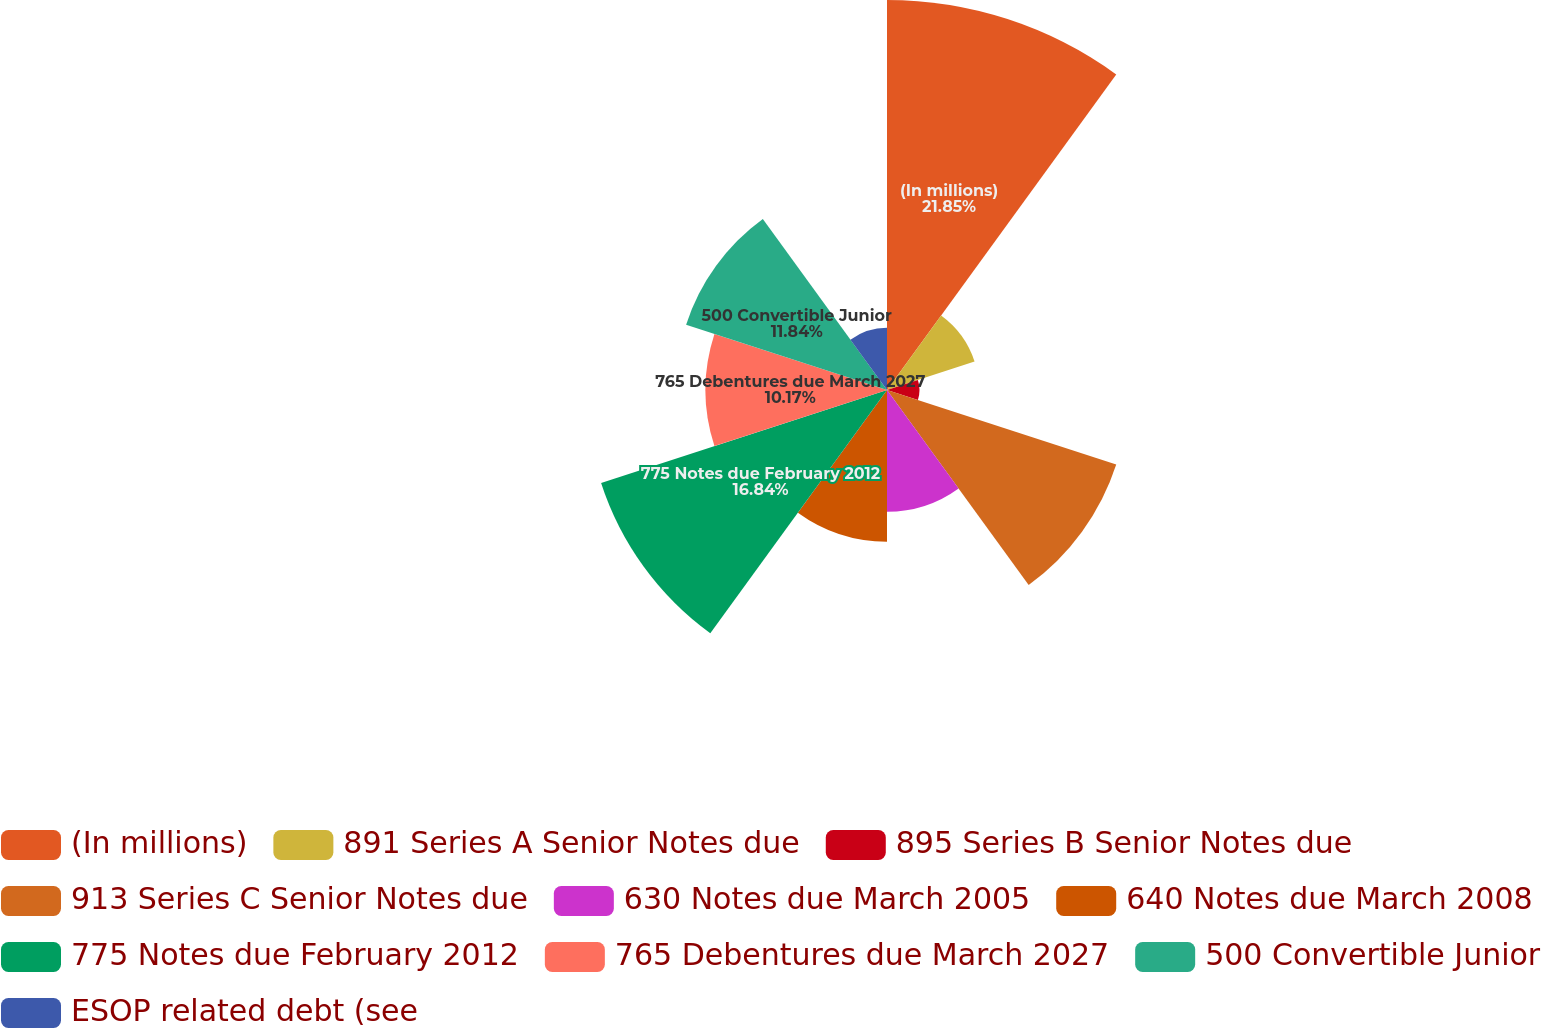Convert chart. <chart><loc_0><loc_0><loc_500><loc_500><pie_chart><fcel>(In millions)<fcel>891 Series A Senior Notes due<fcel>895 Series B Senior Notes due<fcel>913 Series C Senior Notes due<fcel>630 Notes due March 2005<fcel>640 Notes due March 2008<fcel>775 Notes due February 2012<fcel>765 Debentures due March 2027<fcel>500 Convertible Junior<fcel>ESOP related debt (see<nl><fcel>21.86%<fcel>5.16%<fcel>1.82%<fcel>13.51%<fcel>6.83%<fcel>8.5%<fcel>16.85%<fcel>10.17%<fcel>11.84%<fcel>3.49%<nl></chart> 